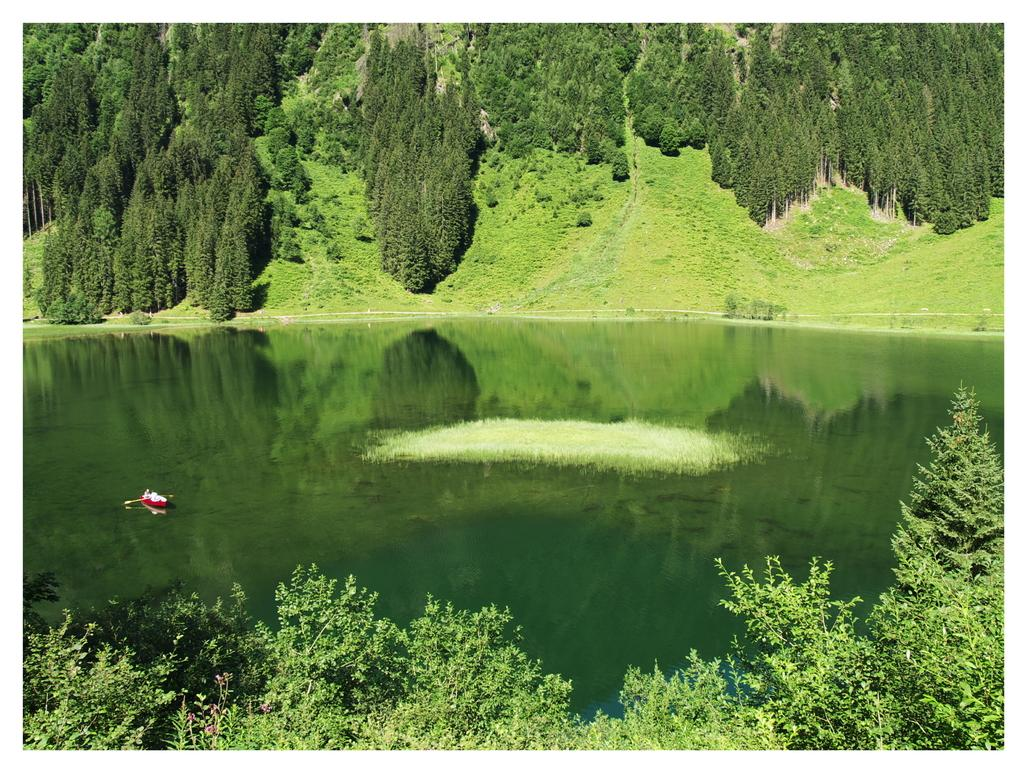What is the main subject of the image? The main subject of the image is a boat. Where is the boat located? The boat is on the water. What can be seen in the background of the image? There are trees and plants in the background of the image. What is the name of the person who baked the pies in the image? There are no pies or people mentioned in the image, so it is not possible to determine the name of the person who baked the pies. 